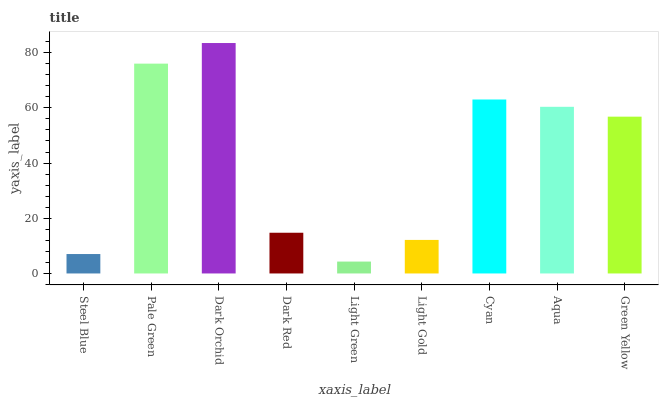Is Light Green the minimum?
Answer yes or no. Yes. Is Dark Orchid the maximum?
Answer yes or no. Yes. Is Pale Green the minimum?
Answer yes or no. No. Is Pale Green the maximum?
Answer yes or no. No. Is Pale Green greater than Steel Blue?
Answer yes or no. Yes. Is Steel Blue less than Pale Green?
Answer yes or no. Yes. Is Steel Blue greater than Pale Green?
Answer yes or no. No. Is Pale Green less than Steel Blue?
Answer yes or no. No. Is Green Yellow the high median?
Answer yes or no. Yes. Is Green Yellow the low median?
Answer yes or no. Yes. Is Light Green the high median?
Answer yes or no. No. Is Pale Green the low median?
Answer yes or no. No. 